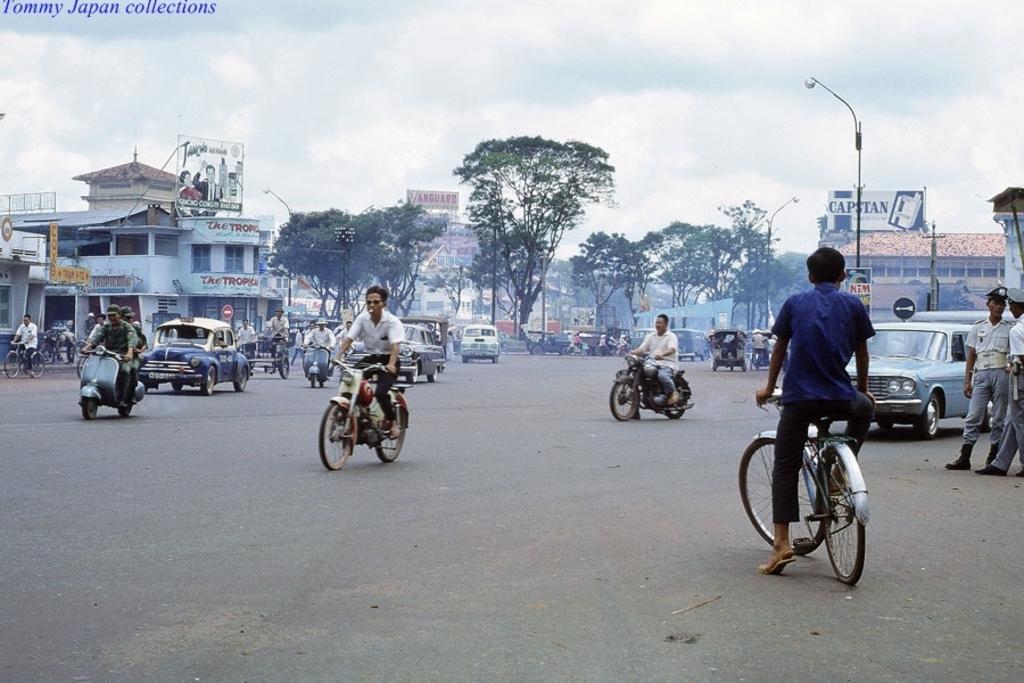In one or two sentences, can you explain what this image depicts? The picture is consists of road side view where, there are cars, bikes, and bicycles and there are some trees around the area and there are two cops those who are standing at the right side of the image. 